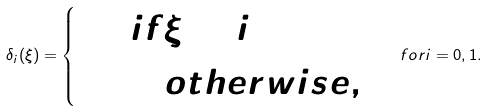<formula> <loc_0><loc_0><loc_500><loc_500>\delta _ { i } ( \xi ) = \begin{cases} 1 & i f \xi = i \\ 0 & \quad o t h e r w i s e , \end{cases} \quad f o r i = 0 , 1 .</formula> 